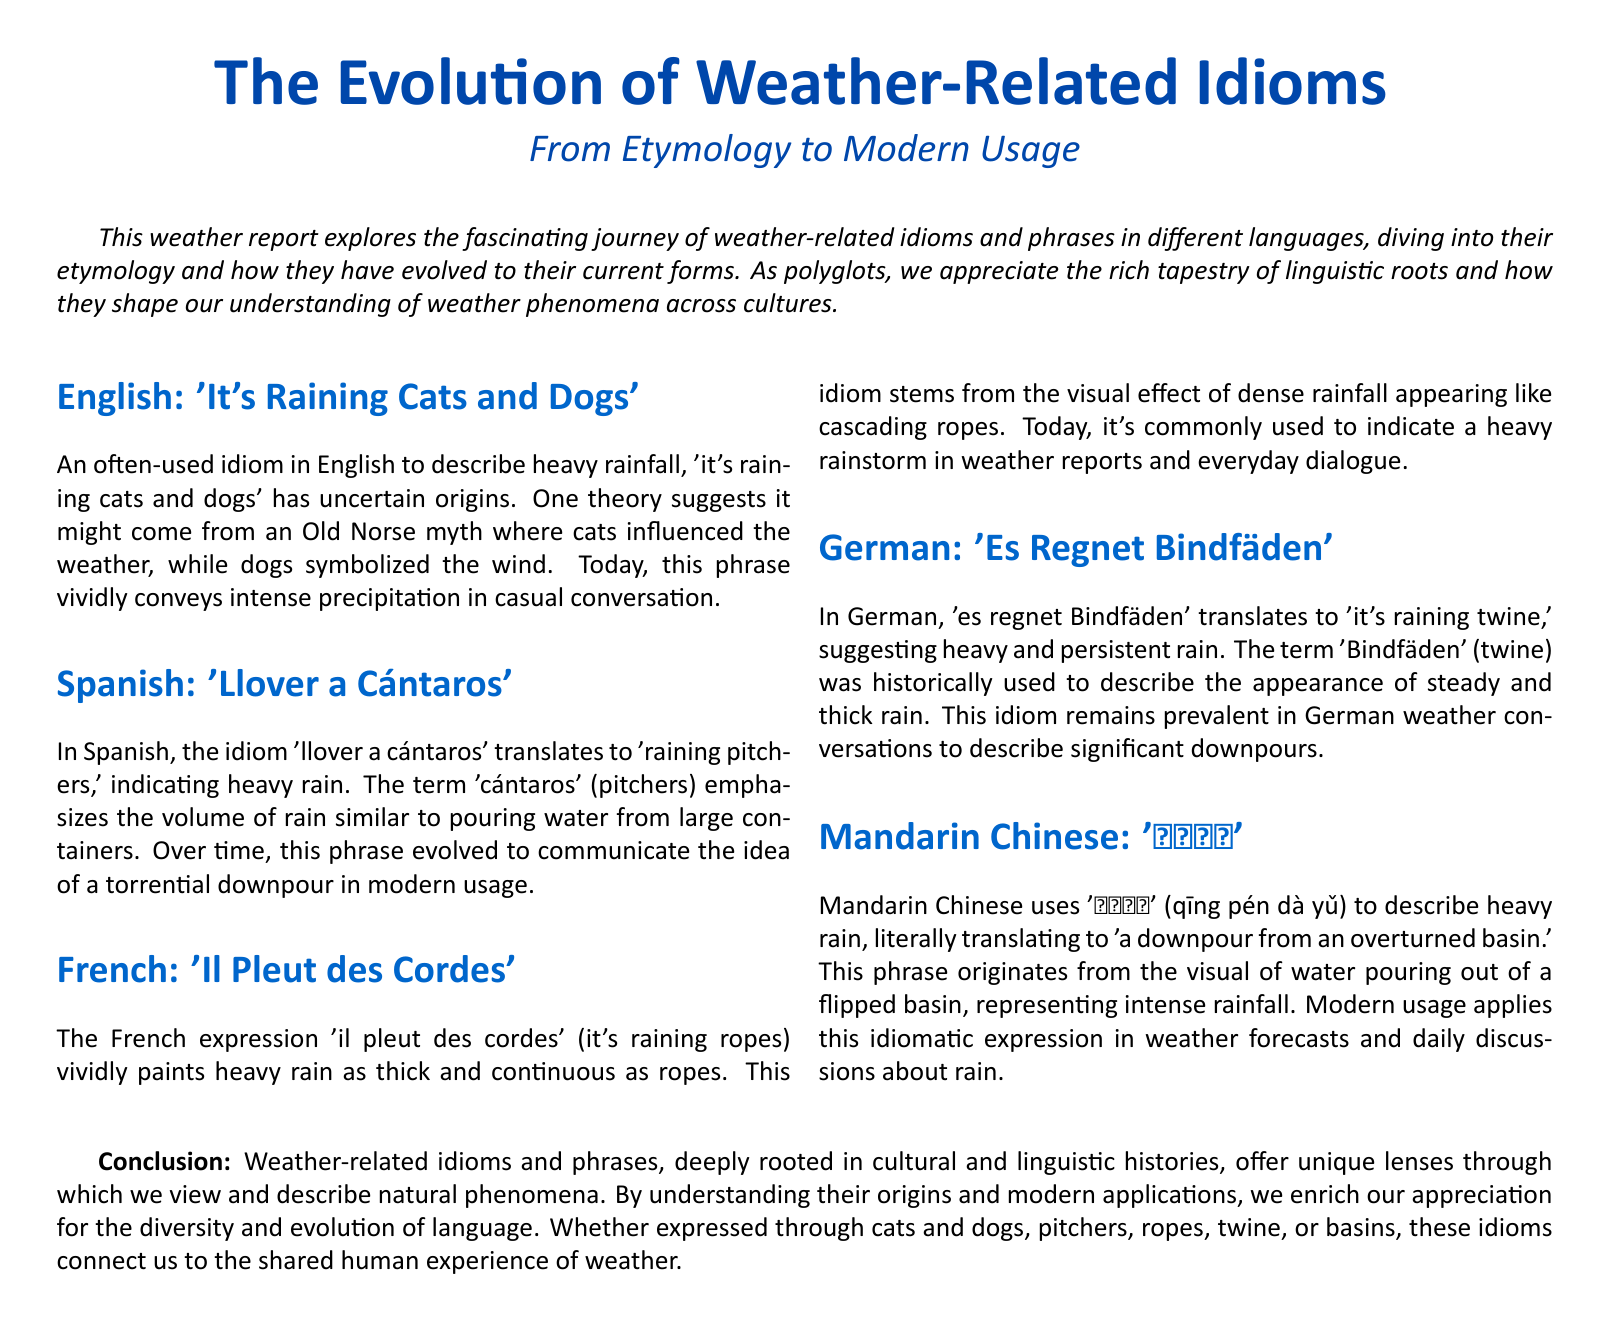What is the idiom for heavy rain in English? The document states that the English idiom for heavy rain is 'it's raining cats and dogs'.
Answer: it's raining cats and dogs What does 'llover a cántaros' mean in English? The document explains that 'llover a cántaros' translates to 'raining pitchers'.
Answer: raining pitchers What visual effect does 'il pleut des cordes' describe? According to the document, 'il pleut des cordes' describes heavy rain as thick and continuous, like ropes.
Answer: thick and continuous like ropes What is the German phrase for heavy rain? The document mentions that the German phrase for heavy rain is 'es regnet Bindfäden'.
Answer: es regnet Bindfäden What does '倾盆大雨' literally translate to? The document states that '倾盆大雨' literally translates to 'a downpour from an overturned basin'.
Answer: a downpour from an overturned basin What common theme connects the idioms described in the document? The document discusses how weather-related idioms are rooted in cultural and linguistic histories.
Answer: cultural and linguistic histories How many languages are discussed in the document? The document details idioms from five languages.
Answer: five In what context is '倾盆大雨' used in modern language? The document indicates that '倾盆大雨' is used in weather forecasts and daily discussions about rain.
Answer: weather forecasts and daily discussions What is the primary focus of the document? The document explores the evolution of weather-related idioms and phrases from etymology to modern usage.
Answer: evolution of weather-related idioms 